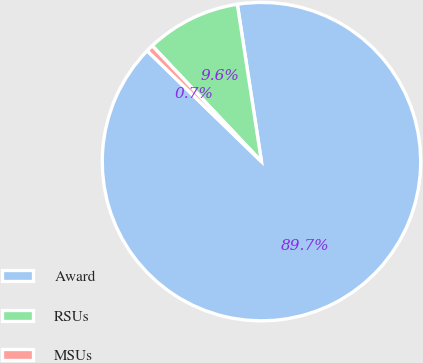Convert chart to OTSL. <chart><loc_0><loc_0><loc_500><loc_500><pie_chart><fcel>Award<fcel>RSUs<fcel>MSUs<nl><fcel>89.68%<fcel>9.61%<fcel>0.71%<nl></chart> 